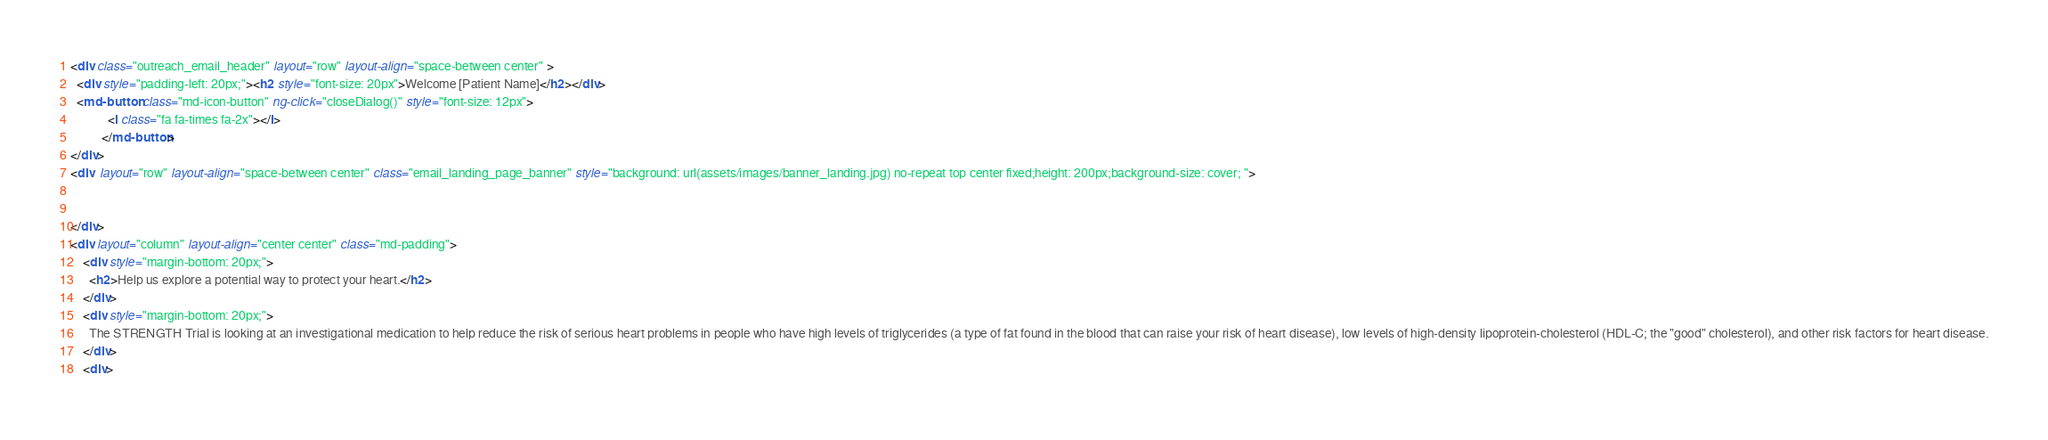<code> <loc_0><loc_0><loc_500><loc_500><_HTML_>

<div class="outreach_email_header" layout="row" layout-align="space-between center" >
  <div style="padding-left: 20px;"><h2 style="font-size: 20px">Welcome [Patient Name]</h2></div>
  <md-button class="md-icon-button" ng-click="closeDialog()" style="font-size: 12px">
            <i class="fa fa-times fa-2x"></i>
          </md-button>
</div>
<div  layout="row" layout-align="space-between center" class="email_landing_page_banner" style="background: url(assets/images/banner_landing.jpg) no-repeat top center fixed;height: 200px;background-size: cover; ">
   

</div>
<div layout="column" layout-align="center center" class="md-padding">
    <div style="margin-bottom: 20px;">
      <h2>Help us explore a potential way to protect your heart.</h2>
    </div>
    <div style="margin-bottom: 20px;">
      The STRENGTH Trial is looking at an investigational medication to help reduce the risk of serious heart problems in people who have high levels of triglycerides (a type of fat found in the blood that can raise your risk of heart disease), low levels of high-density lipoprotein-cholesterol (HDL-C; the "good" cholesterol), and other risk factors for heart disease.
    </div>
    <div></code> 